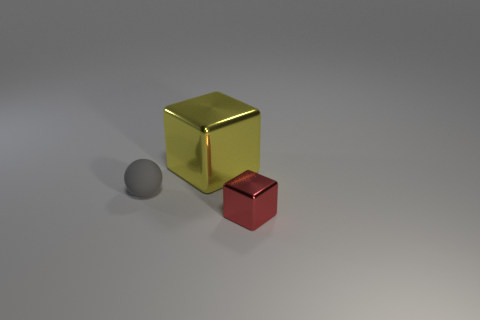Add 3 yellow things. How many objects exist? 6 Subtract all balls. How many objects are left? 2 Subtract 0 blue balls. How many objects are left? 3 Subtract all big cyan shiny blocks. Subtract all metal objects. How many objects are left? 1 Add 1 rubber balls. How many rubber balls are left? 2 Add 1 tiny blue rubber objects. How many tiny blue rubber objects exist? 1 